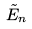Convert formula to latex. <formula><loc_0><loc_0><loc_500><loc_500>\tilde { E } _ { n }</formula> 